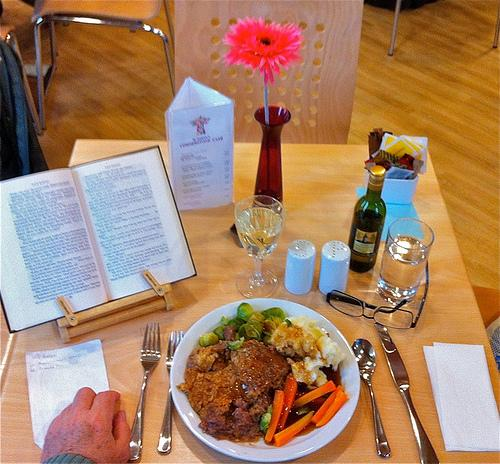Briefly describe the overall atmosphere of the photograph. The image captures a cozy and warm atmosphere in a restaurant setting, with a person enjoying a meal at a round wooden table. What type of utensils can be seen on the table, and how many of each kind are there? There are two forks, one spoon, and one knife seen on the table. Briefly describe the primary object in the image along with its color. The primary object is a white plate placed on a brown round table, showcasing food arranged on the plate. 